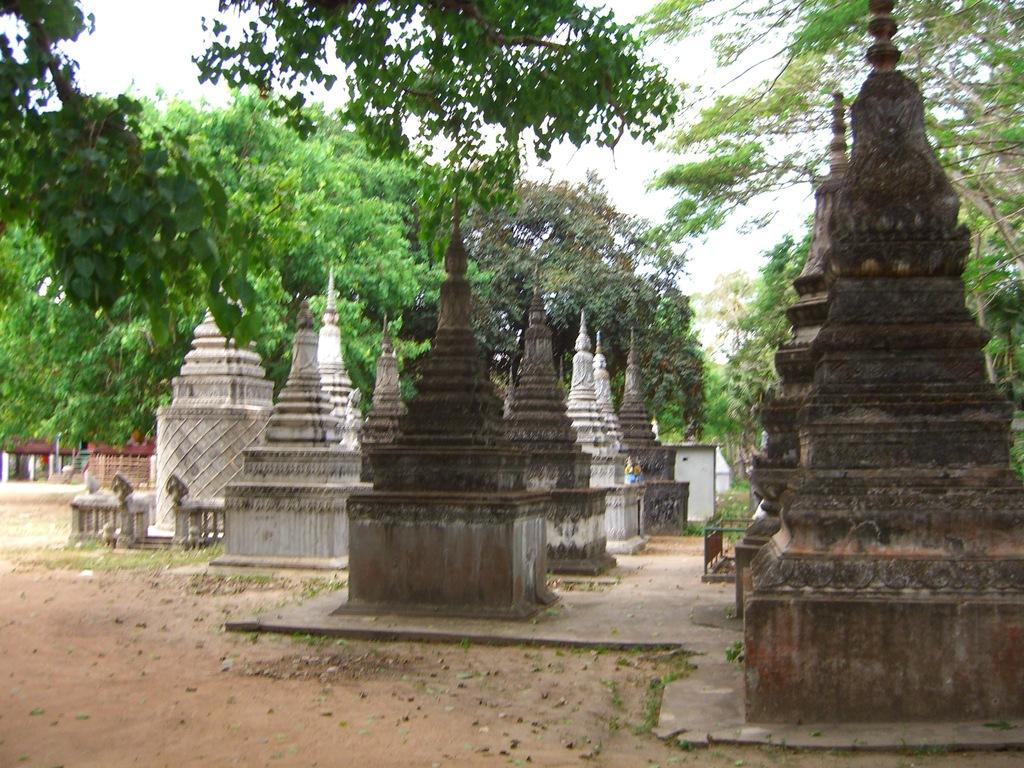What type of buildings can be seen in the image? There are temples in the image. How are the temples arranged in the image? The temples are in a group. What type of vegetation is visible in the image? There are trees visible in the image. What type of structures can be seen besides the temples? There are sheds in the image. How many girls are playing with the drawer in the image? There are no girls or drawers present in the image. 